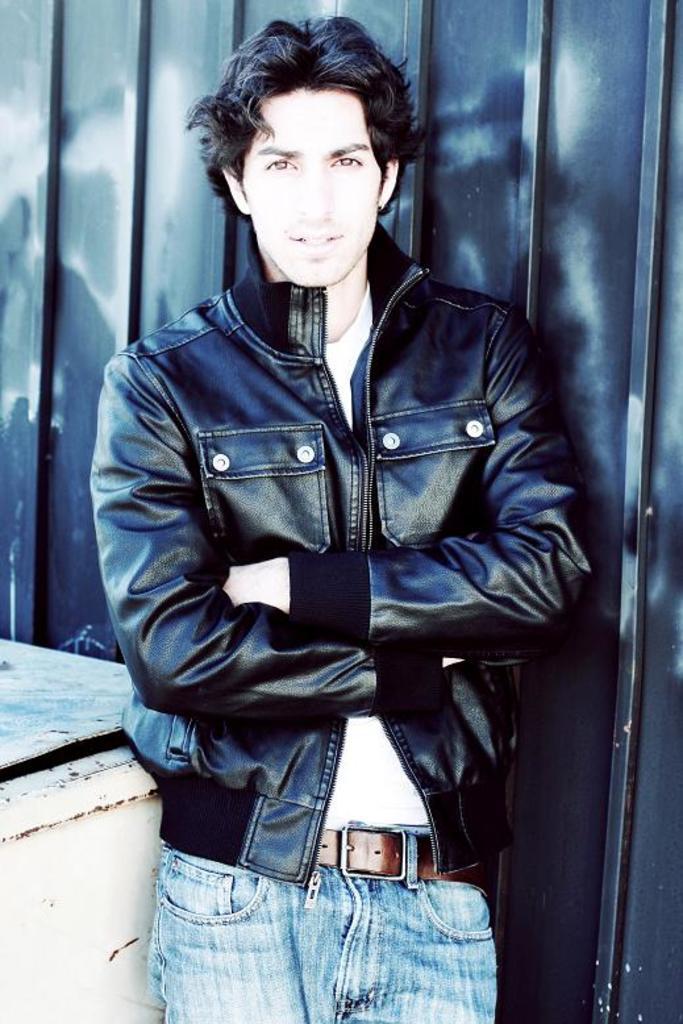Could you give a brief overview of what you see in this image? In this picture there is a man who is wearing jacket and standing near to the wall. 